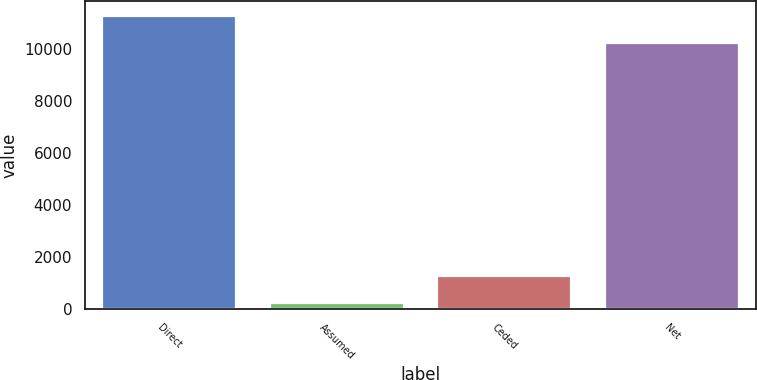Convert chart to OTSL. <chart><loc_0><loc_0><loc_500><loc_500><bar_chart><fcel>Direct<fcel>Assumed<fcel>Ceded<fcel>Net<nl><fcel>11292.3<fcel>218<fcel>1279.3<fcel>10231<nl></chart> 